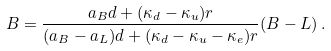<formula> <loc_0><loc_0><loc_500><loc_500>B = \frac { a _ { B } d + ( \kappa _ { d } - \kappa _ { u } ) r } { ( a _ { B } - a _ { L } ) d + ( \kappa _ { d } - \kappa _ { u } - \kappa _ { e } ) r } ( B - L ) \, .</formula> 